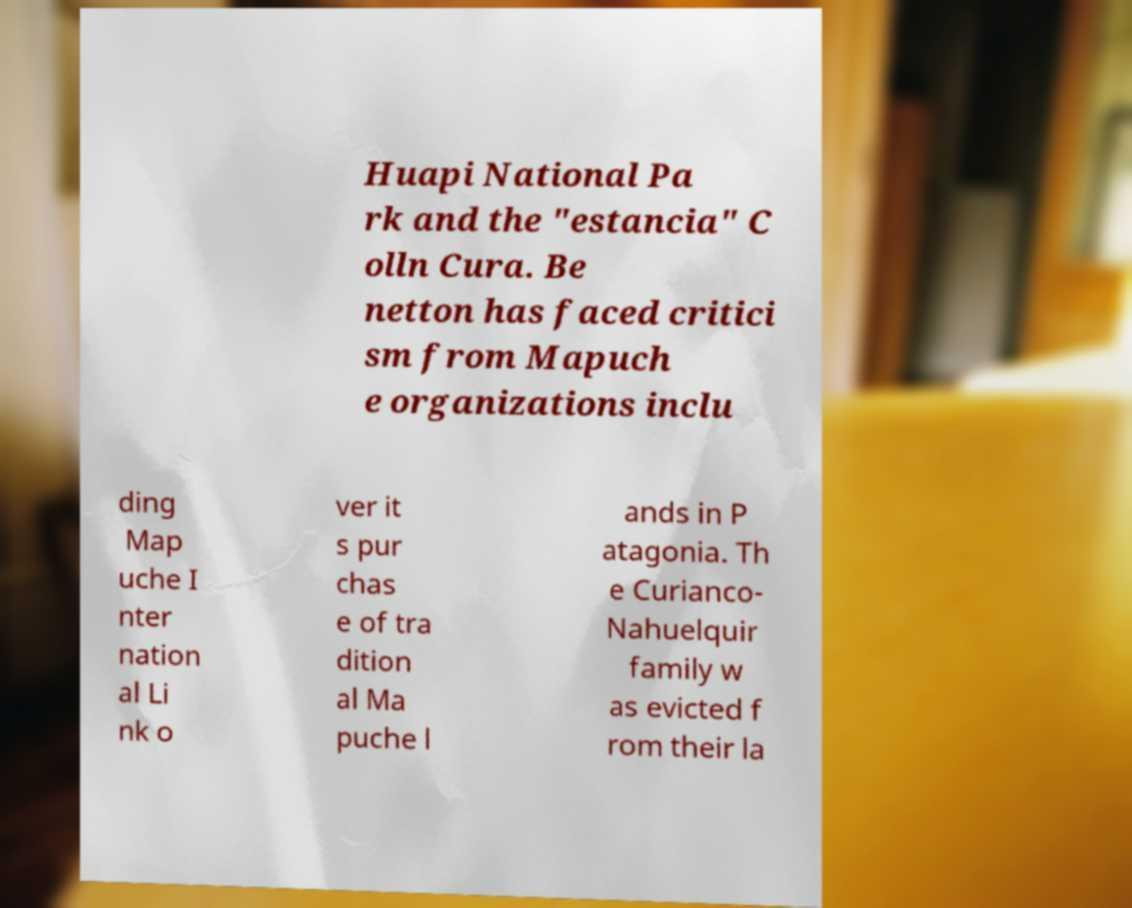Please read and relay the text visible in this image. What does it say? Huapi National Pa rk and the "estancia" C olln Cura. Be netton has faced critici sm from Mapuch e organizations inclu ding Map uche I nter nation al Li nk o ver it s pur chas e of tra dition al Ma puche l ands in P atagonia. Th e Curianco- Nahuelquir family w as evicted f rom their la 